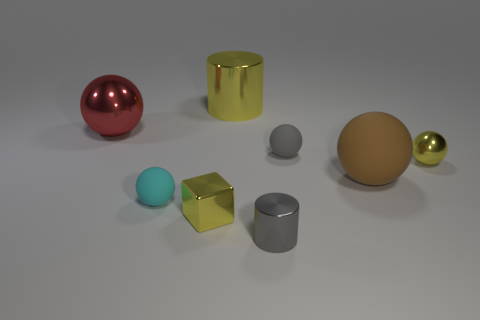Is the number of balls on the right side of the yellow metallic cube the same as the number of small metallic blocks right of the large yellow thing?
Ensure brevity in your answer.  No. There is a matte ball that is left of the tiny yellow metal cube; is there a ball that is in front of it?
Your response must be concise. No. The brown object is what shape?
Keep it short and to the point. Sphere. The sphere that is the same color as the tiny metallic block is what size?
Your answer should be very brief. Small. How big is the yellow shiny thing left of the metal cylinder behind the big brown object?
Offer a very short reply. Small. How big is the cylinder in front of the yellow cylinder?
Provide a succinct answer. Small. Are there fewer small shiny cylinders that are to the left of the big yellow shiny object than tiny gray cylinders that are left of the brown matte object?
Ensure brevity in your answer.  Yes. The big metallic cylinder has what color?
Provide a short and direct response. Yellow. Are there any small things that have the same color as the big cylinder?
Your answer should be very brief. Yes. The big metallic thing left of the yellow thing that is behind the metal sphere to the right of the small gray metal object is what shape?
Offer a very short reply. Sphere. 